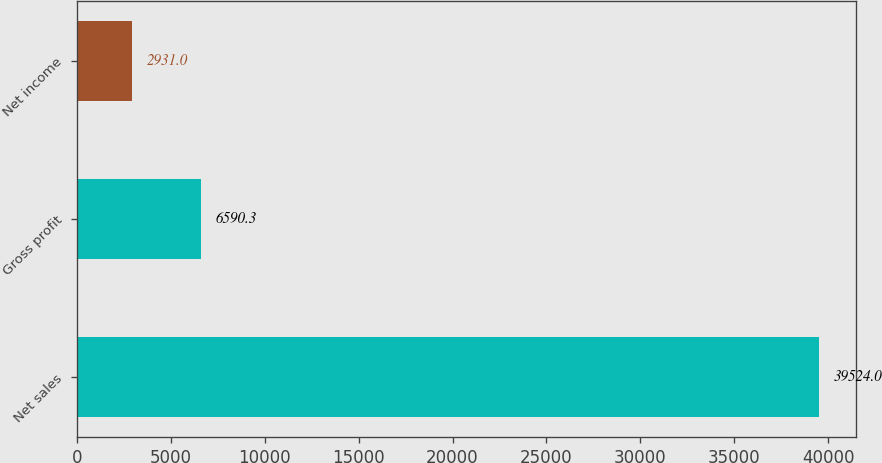Convert chart to OTSL. <chart><loc_0><loc_0><loc_500><loc_500><bar_chart><fcel>Net sales<fcel>Gross profit<fcel>Net income<nl><fcel>39524<fcel>6590.3<fcel>2931<nl></chart> 